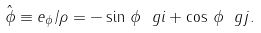<formula> <loc_0><loc_0><loc_500><loc_500>\hat { \phi } \equiv e _ { \phi } / \rho = - \sin \, \phi \ g i + \cos \, \phi \ g j .</formula> 